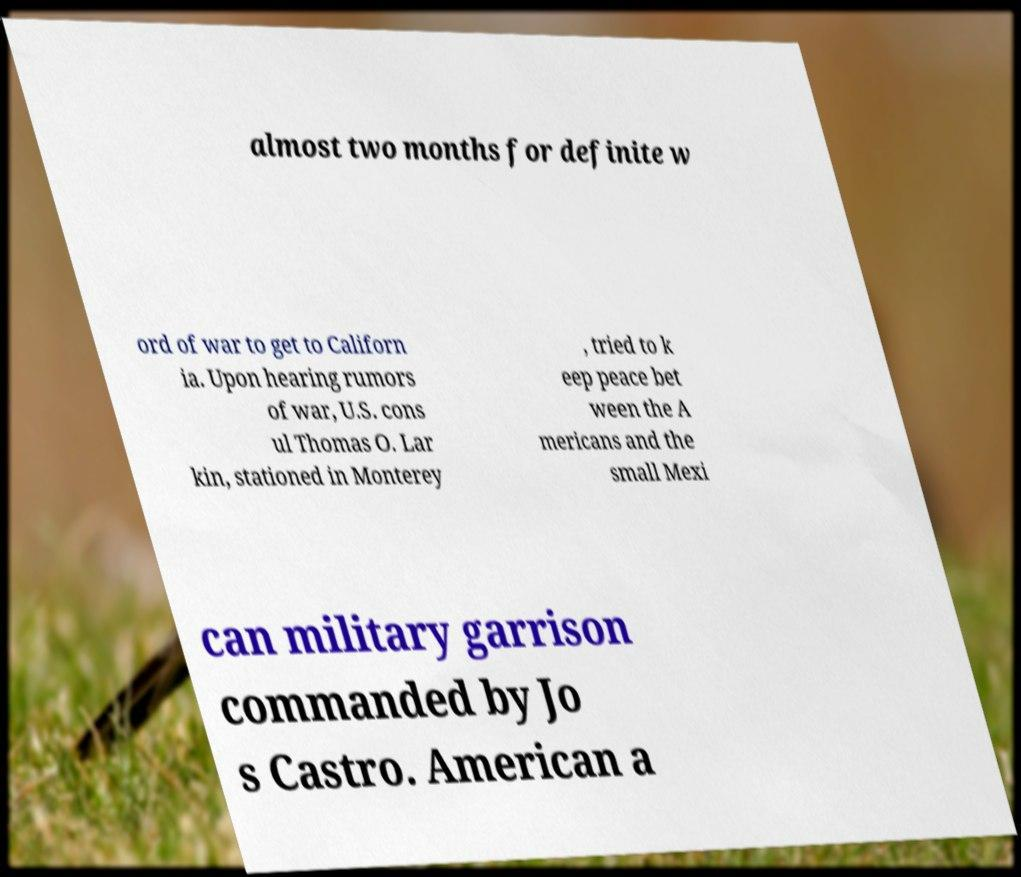Could you extract and type out the text from this image? almost two months for definite w ord of war to get to Californ ia. Upon hearing rumors of war, U.S. cons ul Thomas O. Lar kin, stationed in Monterey , tried to k eep peace bet ween the A mericans and the small Mexi can military garrison commanded by Jo s Castro. American a 